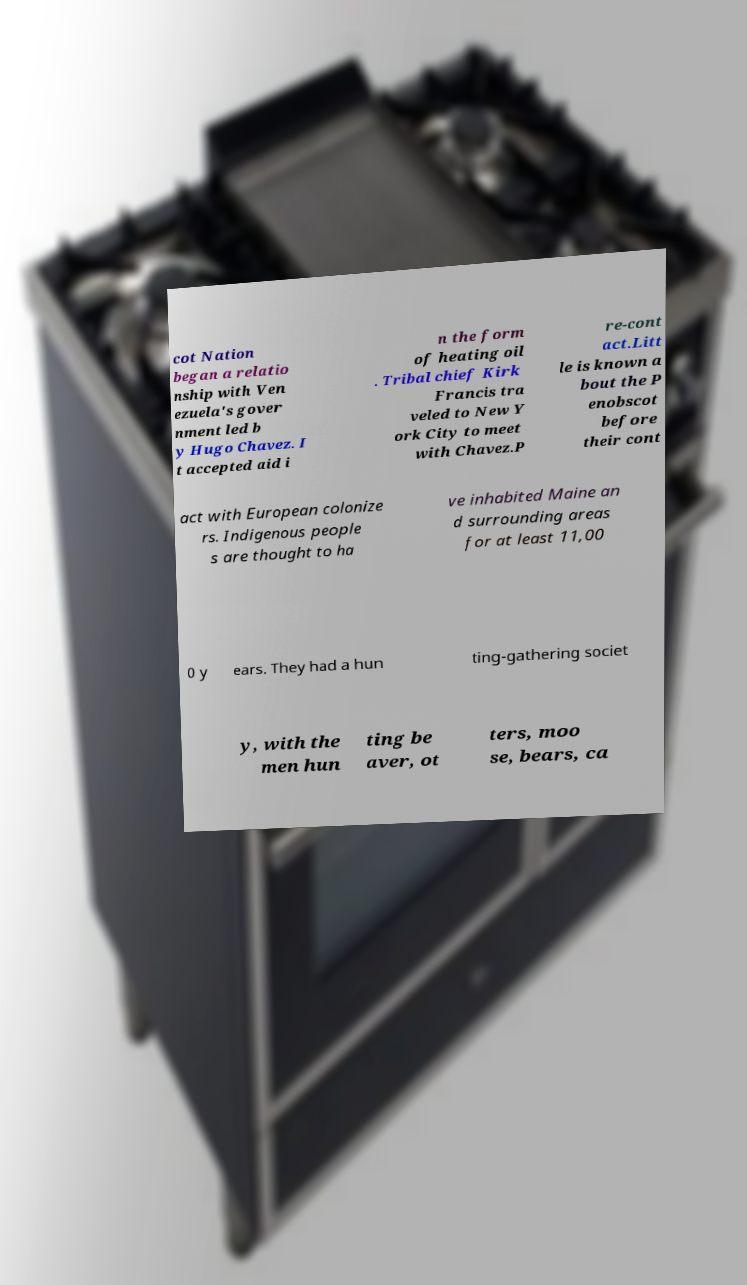What messages or text are displayed in this image? I need them in a readable, typed format. cot Nation began a relatio nship with Ven ezuela's gover nment led b y Hugo Chavez. I t accepted aid i n the form of heating oil . Tribal chief Kirk Francis tra veled to New Y ork City to meet with Chavez.P re-cont act.Litt le is known a bout the P enobscot before their cont act with European colonize rs. Indigenous people s are thought to ha ve inhabited Maine an d surrounding areas for at least 11,00 0 y ears. They had a hun ting-gathering societ y, with the men hun ting be aver, ot ters, moo se, bears, ca 